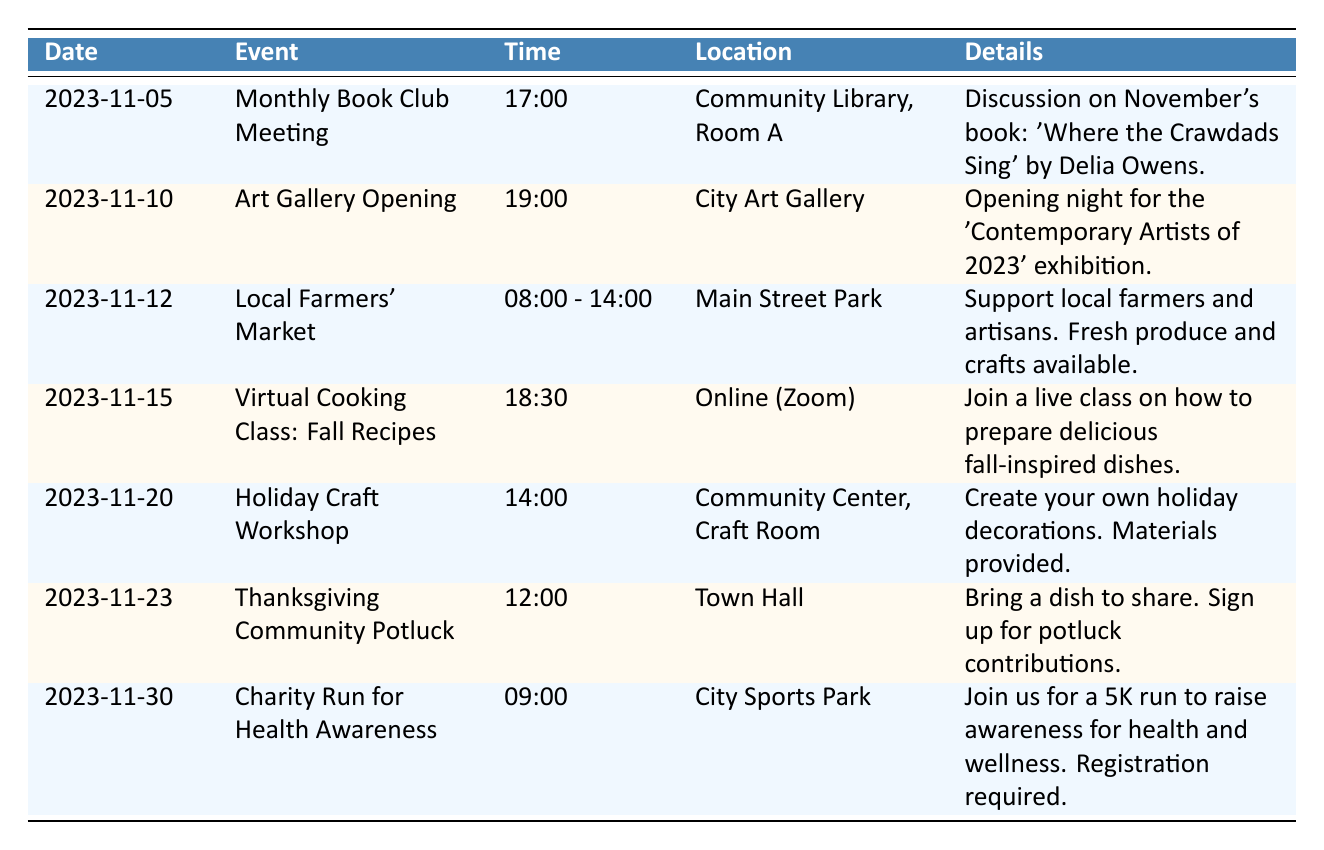What is the date of the Monthly Book Club Meeting? The table lists the date for the Monthly Book Club Meeting directly under the "Date" column, which shows "2023-11-05."
Answer: 2023-11-05 What time does the Art Gallery Opening start? The time for the Art Gallery Opening is provided in the "Time" column of its respective row, listed as "19:00."
Answer: 19:00 Is there an event scheduled on November 12th? Looking at the table, there is indeed an event on November 12th, which is the Local Farmers' Market.
Answer: Yes How many events are happening in November from the 10th to the 20th? The events in that date range are: Art Gallery Opening (11-10), Local Farmers' Market (11-12), and Virtual Cooking Class (11-15). There are 3 events that fit this criteria.
Answer: 3 What is the location of the Holiday Craft Workshop? The location for the Holiday Craft Workshop is under the "Location" column in its row and it is listed as "Community Center, Craft Room."
Answer: Community Center, Craft Room Which event takes place last in November? In the table, the Charity Run for Health Awareness is the last event, dated November 30th. Thus, it occurs last in the month.
Answer: Charity Run for Health Awareness How many total events are taking place in November? By counting all the entries in the table, I find there are 7 events listed for November.
Answer: 7 What is the time span between the Virtual Cooking Class and the Thanksgiving Community Potluck? The Virtual Cooking Class is on November 15th at 18:30, and the Thanksgiving Community Potluck is on November 23rd at 12:00. The time span is 8 days and roughly 17.5 hours, though the key count is 8 days.
Answer: 8 days Is the Local Farmers' Market event all day? The time for the Local Farmers' Market is listed as "08:00 - 14:00," indicating it runs for 6 hours, not all day.
Answer: No 